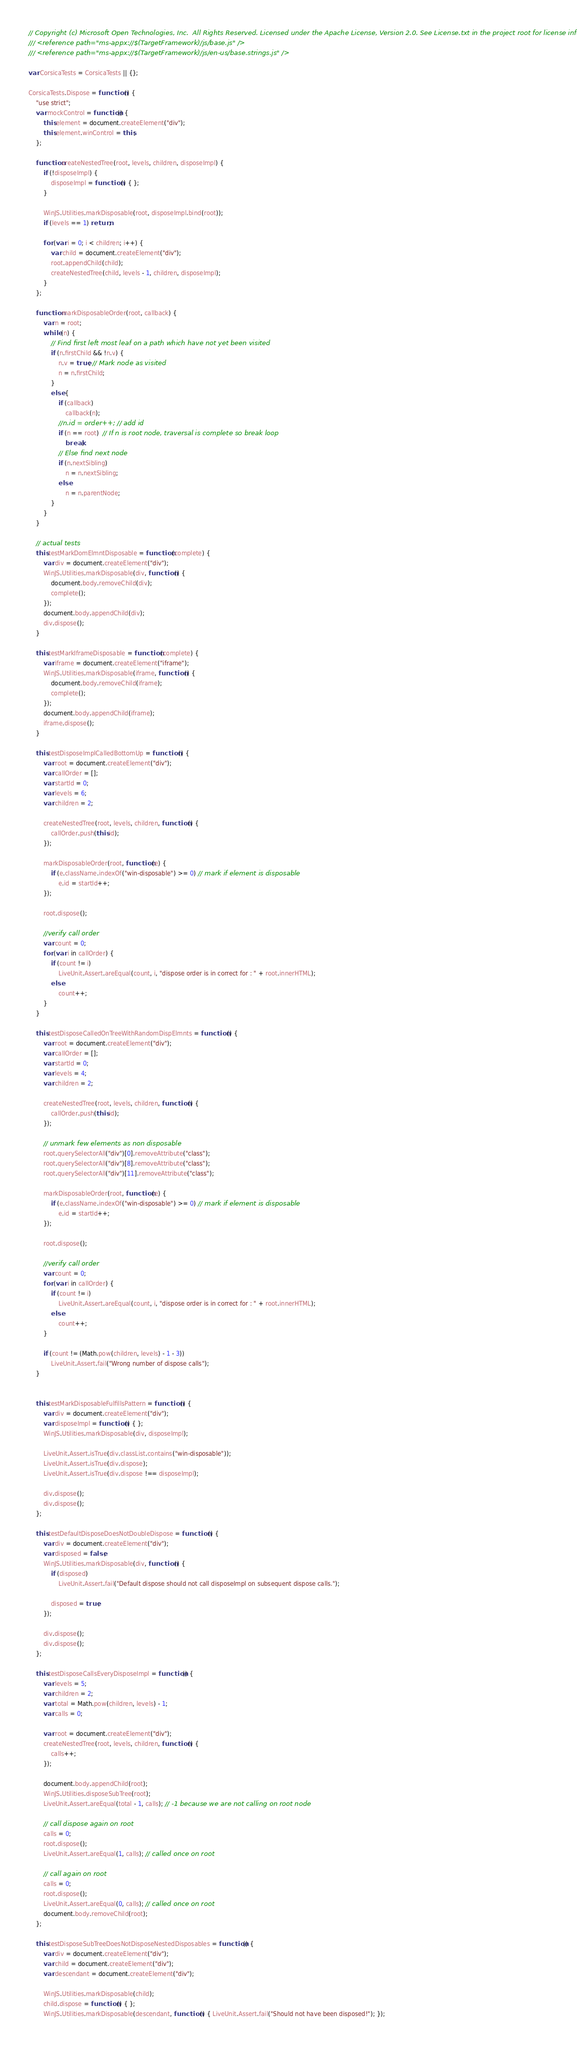<code> <loc_0><loc_0><loc_500><loc_500><_JavaScript_>// Copyright (c) Microsoft Open Technologies, Inc.  All Rights Reserved. Licensed under the Apache License, Version 2.0. See License.txt in the project root for license information.
/// <reference path="ms-appx://$(TargetFramework)/js/base.js" />
/// <reference path="ms-appx://$(TargetFramework)/js/en-us/base.strings.js" />

var CorsicaTests = CorsicaTests || {};

CorsicaTests.Dispose = function () {
    "use strict";
    var mockControl = function() {
        this.element = document.createElement("div");
        this.element.winControl = this;
    };

    function createNestedTree(root, levels, children, disposeImpl) {
        if (!disposeImpl) {
            disposeImpl = function () { };
        }
        
        WinJS.Utilities.markDisposable(root, disposeImpl.bind(root));
        if (levels == 1) return;

        for (var i = 0; i < children; i++) {
            var child = document.createElement("div");            
            root.appendChild(child);
            createNestedTree(child, levels - 1, children, disposeImpl);
        }
    };

    function markDisposableOrder(root, callback) {
        var n = root;
        while (n) {
            // Find first left most leaf on a path which have not yet been visited
            if (n.firstChild && !n.v) {
                n.v = true; // Mark node as visited
                n = n.firstChild;
            }
            else {
                if (callback)
                    callback(n);
                //n.id = order++; // add id
                if (n == root)  // If n is root node, traversal is complete so break loop
                    break;
                // Else find next node
                if (n.nextSibling)
                    n = n.nextSibling;
                else
                    n = n.parentNode;
            }
        }
    }

    // actual tests
    this.testMarkDomElmntDisposable = function (complete) {
        var div = document.createElement("div");
        WinJS.Utilities.markDisposable(div, function () {
            document.body.removeChild(div);
            complete();
        });
        document.body.appendChild(div);
        div.dispose();
    }

    this.testMarkIframeDisposable = function (complete) {
        var iframe = document.createElement("iframe");
        WinJS.Utilities.markDisposable(iframe, function () {
            document.body.removeChild(iframe);
            complete();
        });
        document.body.appendChild(iframe);
        iframe.dispose();
    }

    this.testDisposeImplCalledBottomUp = function () {
        var root = document.createElement("div");
        var callOrder = [];
        var startId = 0;
        var levels = 6;
        var children = 2;

        createNestedTree(root, levels, children, function () {
            callOrder.push(this.id);
        });

        markDisposableOrder(root, function (e) {
            if (e.className.indexOf("win-disposable") >= 0) // mark if element is disposable
                e.id = startId++;
        });

        root.dispose();

        //verify call order
        var count = 0;
        for (var i in callOrder) {
            if (count != i)
                LiveUnit.Assert.areEqual(count, i, "dispose order is in correct for : " + root.innerHTML);
            else
                count++;
        }
    }

    this.testDisposeCalledOnTreeWithRandomDispElmnts = function () {
        var root = document.createElement("div");
        var callOrder = [];
        var startId = 0;
        var levels = 4;
        var children = 2;

        createNestedTree(root, levels, children, function () {
            callOrder.push(this.id);
        });

        // unmark few elements as non disposable
        root.querySelectorAll("div")[0].removeAttribute("class");
        root.querySelectorAll("div")[8].removeAttribute("class");
        root.querySelectorAll("div")[11].removeAttribute("class");

        markDisposableOrder(root, function (e) {
            if (e.className.indexOf("win-disposable") >= 0) // mark if element is disposable
                e.id = startId++;
        });

        root.dispose();

        //verify call order
        var count = 0;
        for (var i in callOrder) {
            if (count != i)
                LiveUnit.Assert.areEqual(count, i, "dispose order is in correct for : " + root.innerHTML);
            else
                count++;
        }

        if (count != (Math.pow(children, levels) - 1 - 3))
            LiveUnit.Assert.fail("Wrong number of dispose calls");
    }


    this.testMarkDisposableFulfillsPattern = function () {
        var div = document.createElement("div");
        var disposeImpl = function () { };
        WinJS.Utilities.markDisposable(div, disposeImpl);

        LiveUnit.Assert.isTrue(div.classList.contains("win-disposable"));
        LiveUnit.Assert.isTrue(div.dispose);
        LiveUnit.Assert.isTrue(div.dispose !== disposeImpl);

        div.dispose();
        div.dispose();
    };
    
    this.testDefaultDisposeDoesNotDoubleDispose = function () {
        var div = document.createElement("div");
        var disposed = false;
        WinJS.Utilities.markDisposable(div, function () {
            if (disposed)
                LiveUnit.Assert.fail("Default dispose should not call disposeImpl on subsequent dispose calls.");

            disposed = true;
        });

        div.dispose();
        div.dispose();
    };
    
    this.testDisposeCallsEveryDisposeImpl = function() {
        var levels = 5;
        var children = 2;
        var total = Math.pow(children, levels) - 1;
        var calls = 0;

        var root = document.createElement("div");
        createNestedTree(root, levels, children, function () {
            calls++;
        });

        document.body.appendChild(root);
        WinJS.Utilities.disposeSubTree(root);
        LiveUnit.Assert.areEqual(total - 1, calls); // -1 because we are not calling on root node

        // call dispose again on root
        calls = 0;
        root.dispose();
        LiveUnit.Assert.areEqual(1, calls); // called once on root

        // call again on root
        calls = 0;
        root.dispose();
        LiveUnit.Assert.areEqual(0, calls); // called once on root
        document.body.removeChild(root);
    };

    this.testDisposeSubTreeDoesNotDisposeNestedDisposables = function() {
        var div = document.createElement("div");
        var child = document.createElement("div");
        var descendant = document.createElement("div");

        WinJS.Utilities.markDisposable(child);
        child.dispose = function () { };
        WinJS.Utilities.markDisposable(descendant, function () { LiveUnit.Assert.fail("Should not have been disposed!"); });
</code> 